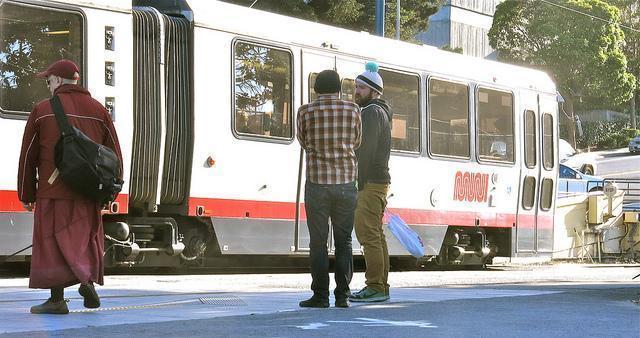What transmits electrical energy to the locomotive here?
Indicate the correct response and explain using: 'Answer: answer
Rationale: rationale.'
Options: Cell tower, gas tank, overhead line, furnace. Answer: overhead line.
Rationale: The overhead line contains electricity which the train runs on. 